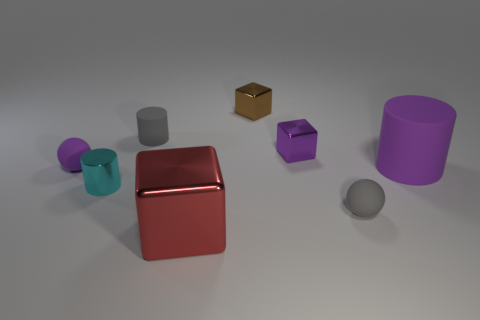Add 1 brown objects. How many objects exist? 9 Subtract all spheres. How many objects are left? 6 Subtract all red metal objects. Subtract all small cyan things. How many objects are left? 6 Add 3 shiny cylinders. How many shiny cylinders are left? 4 Add 5 blue rubber cylinders. How many blue rubber cylinders exist? 5 Subtract 0 brown cylinders. How many objects are left? 8 